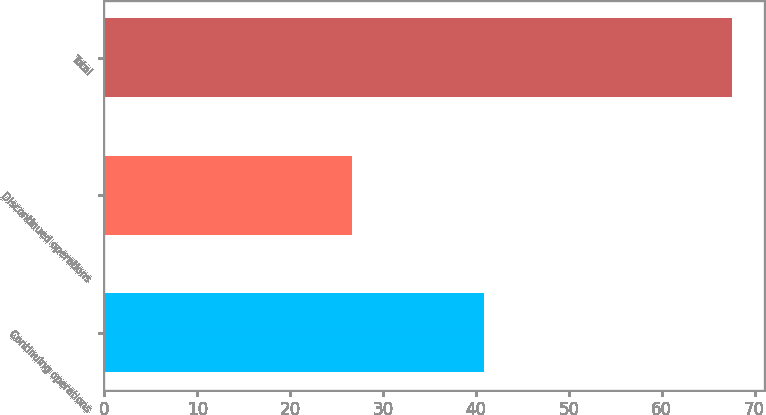<chart> <loc_0><loc_0><loc_500><loc_500><bar_chart><fcel>Continuing operations<fcel>Discontinued operations<fcel>Total<nl><fcel>40.9<fcel>26.7<fcel>67.6<nl></chart> 